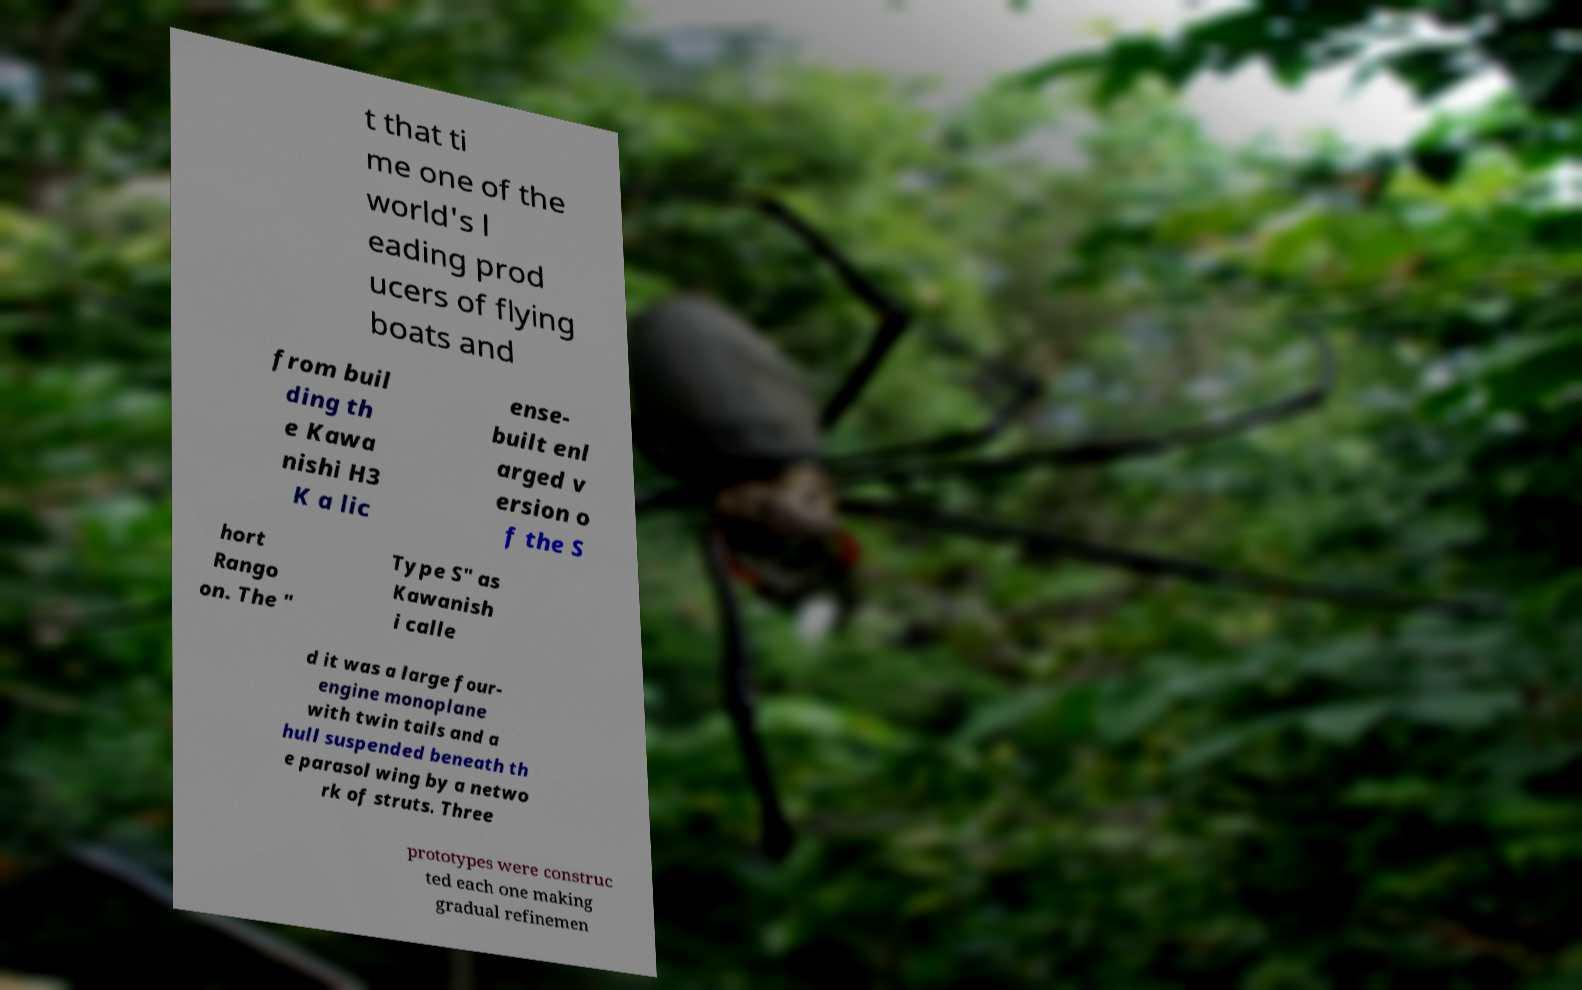I need the written content from this picture converted into text. Can you do that? t that ti me one of the world's l eading prod ucers of flying boats and from buil ding th e Kawa nishi H3 K a lic ense- built enl arged v ersion o f the S hort Rango on. The " Type S" as Kawanish i calle d it was a large four- engine monoplane with twin tails and a hull suspended beneath th e parasol wing by a netwo rk of struts. Three prototypes were construc ted each one making gradual refinemen 